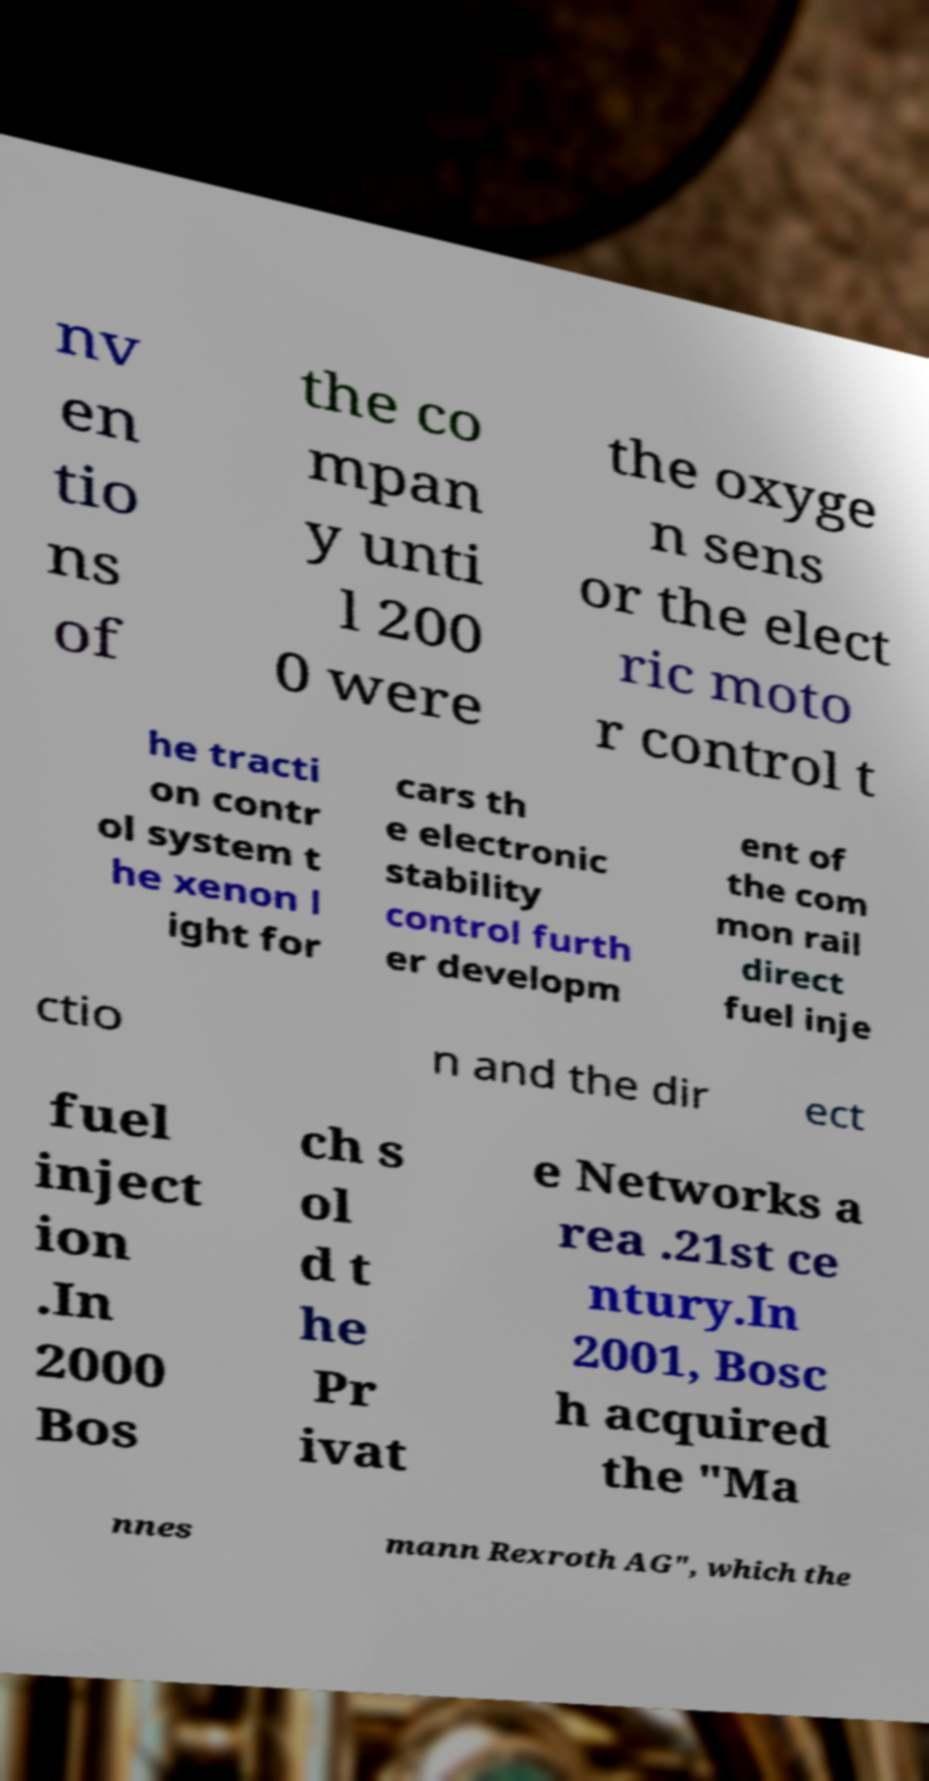What messages or text are displayed in this image? I need them in a readable, typed format. nv en tio ns of the co mpan y unti l 200 0 were the oxyge n sens or the elect ric moto r control t he tracti on contr ol system t he xenon l ight for cars th e electronic stability control furth er developm ent of the com mon rail direct fuel inje ctio n and the dir ect fuel inject ion .In 2000 Bos ch s ol d t he Pr ivat e Networks a rea .21st ce ntury.In 2001, Bosc h acquired the "Ma nnes mann Rexroth AG", which the 